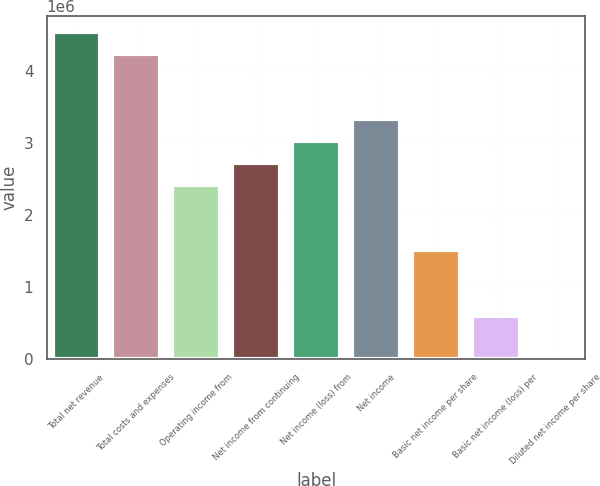Convert chart. <chart><loc_0><loc_0><loc_500><loc_500><bar_chart><fcel>Total net revenue<fcel>Total costs and expenses<fcel>Operating income from<fcel>Net income from continuing<fcel>Net income (loss) from<fcel>Net income<fcel>Basic net income per share<fcel>Basic net income (loss) per<fcel>Diluted net income per share<nl><fcel>4.54261e+06<fcel>4.23977e+06<fcel>2.42272e+06<fcel>2.72556e+06<fcel>3.02841e+06<fcel>3.33125e+06<fcel>1.5142e+06<fcel>605681<fcel>0.12<nl></chart> 